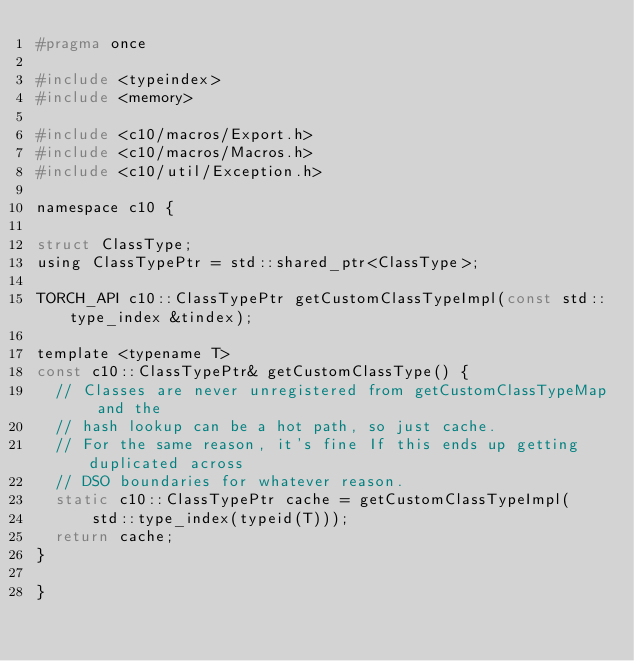<code> <loc_0><loc_0><loc_500><loc_500><_C_>#pragma once

#include <typeindex>
#include <memory>

#include <c10/macros/Export.h>
#include <c10/macros/Macros.h>
#include <c10/util/Exception.h>

namespace c10 {

struct ClassType;
using ClassTypePtr = std::shared_ptr<ClassType>;

TORCH_API c10::ClassTypePtr getCustomClassTypeImpl(const std::type_index &tindex);

template <typename T>
const c10::ClassTypePtr& getCustomClassType() {
  // Classes are never unregistered from getCustomClassTypeMap and the
  // hash lookup can be a hot path, so just cache.
  // For the same reason, it's fine If this ends up getting duplicated across
  // DSO boundaries for whatever reason.
  static c10::ClassTypePtr cache = getCustomClassTypeImpl(
      std::type_index(typeid(T)));
  return cache;
}

}
</code> 